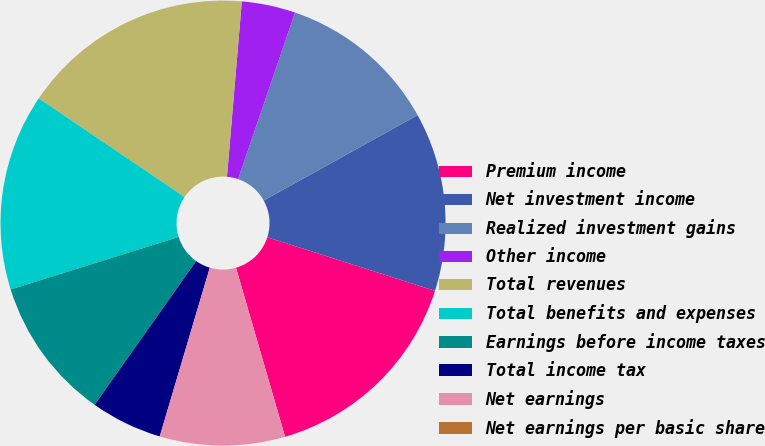Convert chart. <chart><loc_0><loc_0><loc_500><loc_500><pie_chart><fcel>Premium income<fcel>Net investment income<fcel>Realized investment gains<fcel>Other income<fcel>Total revenues<fcel>Total benefits and expenses<fcel>Earnings before income taxes<fcel>Total income tax<fcel>Net earnings<fcel>Net earnings per basic share<nl><fcel>15.58%<fcel>12.99%<fcel>11.69%<fcel>3.9%<fcel>16.88%<fcel>14.29%<fcel>10.39%<fcel>5.2%<fcel>9.09%<fcel>0.0%<nl></chart> 